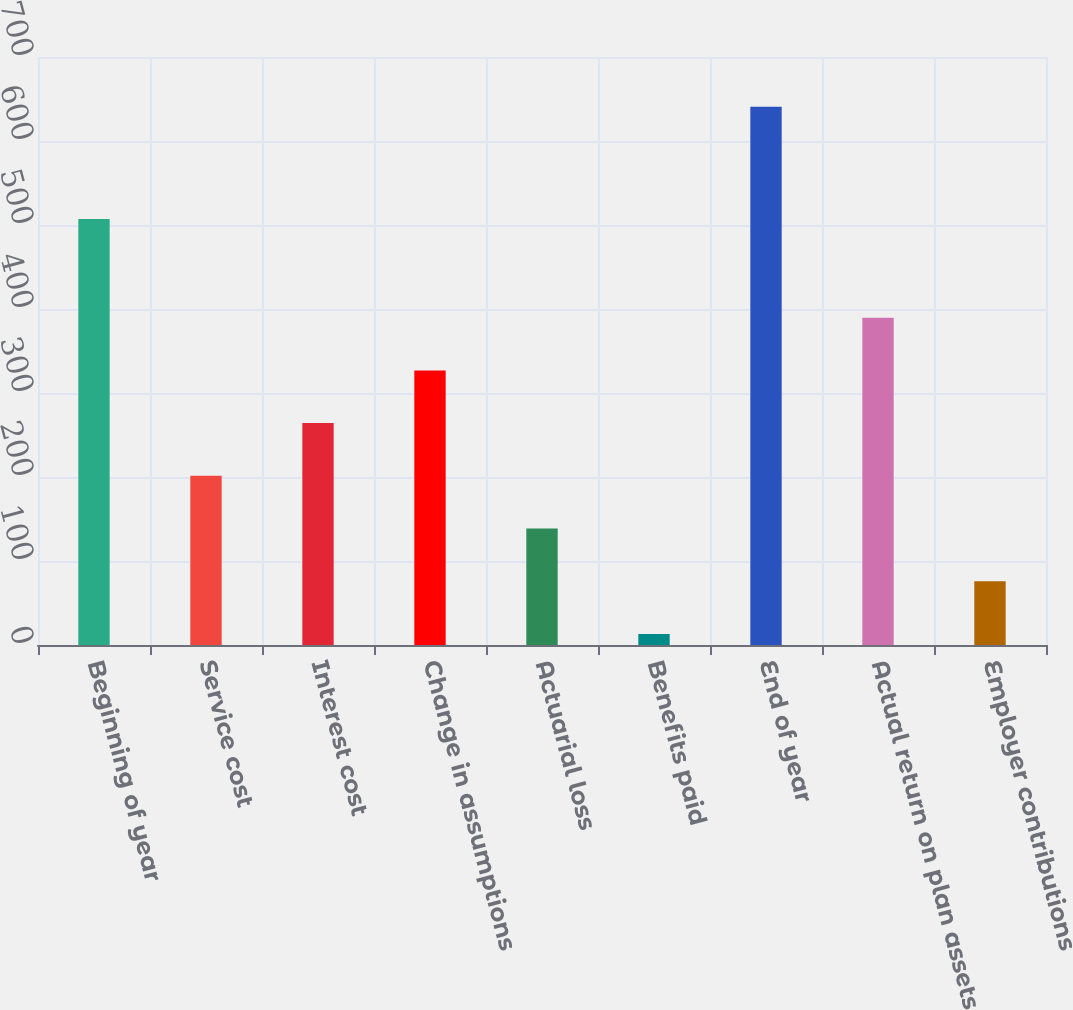<chart> <loc_0><loc_0><loc_500><loc_500><bar_chart><fcel>Beginning of year<fcel>Service cost<fcel>Interest cost<fcel>Change in assumptions<fcel>Actuarial loss<fcel>Benefits paid<fcel>End of year<fcel>Actual return on plan assets<fcel>Employer contributions<nl><fcel>507.2<fcel>201.38<fcel>264.14<fcel>326.9<fcel>138.62<fcel>13.1<fcel>640.7<fcel>389.66<fcel>75.86<nl></chart> 